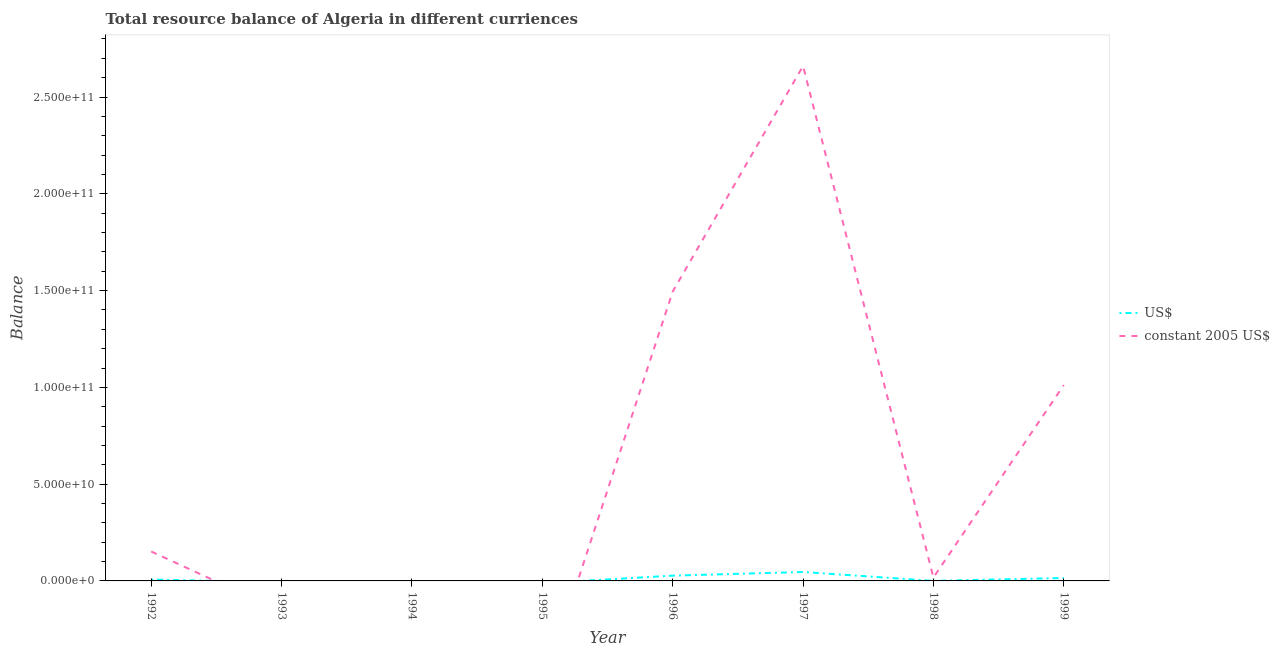How many different coloured lines are there?
Your response must be concise. 2. Does the line corresponding to resource balance in constant us$ intersect with the line corresponding to resource balance in us$?
Ensure brevity in your answer.  Yes. Is the number of lines equal to the number of legend labels?
Offer a terse response. No. What is the resource balance in constant us$ in 1999?
Give a very brief answer. 1.01e+11. Across all years, what is the maximum resource balance in us$?
Provide a succinct answer. 4.61e+09. What is the total resource balance in us$ in the graph?
Provide a short and direct response. 9.59e+09. What is the difference between the resource balance in constant us$ in 1996 and that in 1998?
Provide a short and direct response. 1.48e+11. What is the difference between the resource balance in us$ in 1993 and the resource balance in constant us$ in 1999?
Your answer should be very brief. -1.01e+11. What is the average resource balance in constant us$ per year?
Your answer should be compact. 6.67e+1. In the year 1999, what is the difference between the resource balance in us$ and resource balance in constant us$?
Provide a succinct answer. -9.97e+1. What is the ratio of the resource balance in us$ in 1992 to that in 1996?
Your response must be concise. 0.25. What is the difference between the highest and the second highest resource balance in us$?
Keep it short and to the point. 1.88e+09. What is the difference between the highest and the lowest resource balance in us$?
Your answer should be very brief. 4.61e+09. In how many years, is the resource balance in us$ greater than the average resource balance in us$ taken over all years?
Offer a terse response. 3. Does the resource balance in constant us$ monotonically increase over the years?
Offer a terse response. No. Is the resource balance in constant us$ strictly less than the resource balance in us$ over the years?
Your answer should be very brief. No. How many lines are there?
Provide a short and direct response. 2. What is the difference between two consecutive major ticks on the Y-axis?
Your answer should be compact. 5.00e+1. Are the values on the major ticks of Y-axis written in scientific E-notation?
Provide a short and direct response. Yes. Where does the legend appear in the graph?
Keep it short and to the point. Center right. How many legend labels are there?
Your answer should be very brief. 2. How are the legend labels stacked?
Make the answer very short. Vertical. What is the title of the graph?
Make the answer very short. Total resource balance of Algeria in different curriences. What is the label or title of the X-axis?
Make the answer very short. Year. What is the label or title of the Y-axis?
Your answer should be compact. Balance. What is the Balance in US$ in 1992?
Your answer should be compact. 6.96e+08. What is the Balance in constant 2005 US$ in 1992?
Provide a short and direct response. 1.52e+1. What is the Balance of constant 2005 US$ in 1993?
Ensure brevity in your answer.  0. What is the Balance in constant 2005 US$ in 1994?
Ensure brevity in your answer.  0. What is the Balance of constant 2005 US$ in 1995?
Offer a terse response. 0. What is the Balance in US$ in 1996?
Ensure brevity in your answer.  2.73e+09. What is the Balance of constant 2005 US$ in 1996?
Offer a terse response. 1.49e+11. What is the Balance of US$ in 1997?
Provide a succinct answer. 4.61e+09. What is the Balance of constant 2005 US$ in 1997?
Keep it short and to the point. 2.66e+11. What is the Balance of US$ in 1998?
Your answer should be compact. 3.00e+07. What is the Balance in constant 2005 US$ in 1998?
Make the answer very short. 1.76e+09. What is the Balance in US$ in 1999?
Ensure brevity in your answer.  1.52e+09. What is the Balance in constant 2005 US$ in 1999?
Ensure brevity in your answer.  1.01e+11. Across all years, what is the maximum Balance of US$?
Provide a succinct answer. 4.61e+09. Across all years, what is the maximum Balance of constant 2005 US$?
Ensure brevity in your answer.  2.66e+11. Across all years, what is the minimum Balance in US$?
Your response must be concise. 0. Across all years, what is the minimum Balance of constant 2005 US$?
Offer a terse response. 0. What is the total Balance in US$ in the graph?
Offer a very short reply. 9.59e+09. What is the total Balance in constant 2005 US$ in the graph?
Your answer should be compact. 5.34e+11. What is the difference between the Balance of US$ in 1992 and that in 1996?
Your response must be concise. -2.03e+09. What is the difference between the Balance of constant 2005 US$ in 1992 and that in 1996?
Make the answer very short. -1.34e+11. What is the difference between the Balance in US$ in 1992 and that in 1997?
Give a very brief answer. -3.91e+09. What is the difference between the Balance of constant 2005 US$ in 1992 and that in 1997?
Provide a succinct answer. -2.51e+11. What is the difference between the Balance in US$ in 1992 and that in 1998?
Offer a terse response. 6.66e+08. What is the difference between the Balance of constant 2005 US$ in 1992 and that in 1998?
Your response must be concise. 1.34e+1. What is the difference between the Balance of US$ in 1992 and that in 1999?
Your answer should be very brief. -8.24e+08. What is the difference between the Balance in constant 2005 US$ in 1992 and that in 1999?
Provide a succinct answer. -8.60e+1. What is the difference between the Balance of US$ in 1996 and that in 1997?
Your answer should be very brief. -1.88e+09. What is the difference between the Balance of constant 2005 US$ in 1996 and that in 1997?
Make the answer very short. -1.17e+11. What is the difference between the Balance of US$ in 1996 and that in 1998?
Keep it short and to the point. 2.70e+09. What is the difference between the Balance of constant 2005 US$ in 1996 and that in 1998?
Offer a very short reply. 1.48e+11. What is the difference between the Balance of US$ in 1996 and that in 1999?
Your response must be concise. 1.21e+09. What is the difference between the Balance in constant 2005 US$ in 1996 and that in 1999?
Your response must be concise. 4.83e+1. What is the difference between the Balance in US$ in 1997 and that in 1998?
Your answer should be compact. 4.58e+09. What is the difference between the Balance in constant 2005 US$ in 1997 and that in 1998?
Provide a short and direct response. 2.64e+11. What is the difference between the Balance of US$ in 1997 and that in 1999?
Offer a terse response. 3.09e+09. What is the difference between the Balance in constant 2005 US$ in 1997 and that in 1999?
Your response must be concise. 1.65e+11. What is the difference between the Balance in US$ in 1998 and that in 1999?
Ensure brevity in your answer.  -1.49e+09. What is the difference between the Balance in constant 2005 US$ in 1998 and that in 1999?
Your answer should be very brief. -9.94e+1. What is the difference between the Balance of US$ in 1992 and the Balance of constant 2005 US$ in 1996?
Give a very brief answer. -1.49e+11. What is the difference between the Balance in US$ in 1992 and the Balance in constant 2005 US$ in 1997?
Offer a very short reply. -2.65e+11. What is the difference between the Balance in US$ in 1992 and the Balance in constant 2005 US$ in 1998?
Offer a terse response. -1.07e+09. What is the difference between the Balance in US$ in 1992 and the Balance in constant 2005 US$ in 1999?
Provide a succinct answer. -1.00e+11. What is the difference between the Balance in US$ in 1996 and the Balance in constant 2005 US$ in 1997?
Give a very brief answer. -2.63e+11. What is the difference between the Balance of US$ in 1996 and the Balance of constant 2005 US$ in 1998?
Your answer should be very brief. 9.68e+08. What is the difference between the Balance of US$ in 1996 and the Balance of constant 2005 US$ in 1999?
Offer a very short reply. -9.85e+1. What is the difference between the Balance in US$ in 1997 and the Balance in constant 2005 US$ in 1998?
Your answer should be very brief. 2.85e+09. What is the difference between the Balance in US$ in 1997 and the Balance in constant 2005 US$ in 1999?
Keep it short and to the point. -9.66e+1. What is the difference between the Balance in US$ in 1998 and the Balance in constant 2005 US$ in 1999?
Ensure brevity in your answer.  -1.01e+11. What is the average Balance in US$ per year?
Offer a very short reply. 1.20e+09. What is the average Balance of constant 2005 US$ per year?
Give a very brief answer. 6.67e+1. In the year 1992, what is the difference between the Balance of US$ and Balance of constant 2005 US$?
Give a very brief answer. -1.45e+1. In the year 1996, what is the difference between the Balance of US$ and Balance of constant 2005 US$?
Offer a terse response. -1.47e+11. In the year 1997, what is the difference between the Balance in US$ and Balance in constant 2005 US$?
Make the answer very short. -2.61e+11. In the year 1998, what is the difference between the Balance in US$ and Balance in constant 2005 US$?
Your answer should be very brief. -1.73e+09. In the year 1999, what is the difference between the Balance of US$ and Balance of constant 2005 US$?
Offer a very short reply. -9.97e+1. What is the ratio of the Balance of US$ in 1992 to that in 1996?
Give a very brief answer. 0.26. What is the ratio of the Balance of constant 2005 US$ in 1992 to that in 1996?
Your answer should be compact. 0.1. What is the ratio of the Balance of US$ in 1992 to that in 1997?
Your answer should be compact. 0.15. What is the ratio of the Balance of constant 2005 US$ in 1992 to that in 1997?
Your answer should be very brief. 0.06. What is the ratio of the Balance in US$ in 1992 to that in 1998?
Give a very brief answer. 23.2. What is the ratio of the Balance of constant 2005 US$ in 1992 to that in 1998?
Your response must be concise. 8.63. What is the ratio of the Balance in US$ in 1992 to that in 1999?
Your answer should be compact. 0.46. What is the ratio of the Balance of constant 2005 US$ in 1992 to that in 1999?
Ensure brevity in your answer.  0.15. What is the ratio of the Balance in US$ in 1996 to that in 1997?
Your response must be concise. 0.59. What is the ratio of the Balance of constant 2005 US$ in 1996 to that in 1997?
Make the answer very short. 0.56. What is the ratio of the Balance of US$ in 1996 to that in 1998?
Offer a very short reply. 91. What is the ratio of the Balance of constant 2005 US$ in 1996 to that in 1998?
Offer a terse response. 84.82. What is the ratio of the Balance in US$ in 1996 to that in 1999?
Ensure brevity in your answer.  1.8. What is the ratio of the Balance in constant 2005 US$ in 1996 to that in 1999?
Your answer should be very brief. 1.48. What is the ratio of the Balance of US$ in 1997 to that in 1998?
Offer a terse response. 153.66. What is the ratio of the Balance of constant 2005 US$ in 1997 to that in 1998?
Your answer should be compact. 150.96. What is the ratio of the Balance of US$ in 1997 to that in 1999?
Your answer should be very brief. 3.03. What is the ratio of the Balance of constant 2005 US$ in 1997 to that in 1999?
Provide a short and direct response. 2.63. What is the ratio of the Balance in US$ in 1998 to that in 1999?
Make the answer very short. 0.02. What is the ratio of the Balance in constant 2005 US$ in 1998 to that in 1999?
Make the answer very short. 0.02. What is the difference between the highest and the second highest Balance of US$?
Your answer should be very brief. 1.88e+09. What is the difference between the highest and the second highest Balance in constant 2005 US$?
Provide a short and direct response. 1.17e+11. What is the difference between the highest and the lowest Balance of US$?
Provide a short and direct response. 4.61e+09. What is the difference between the highest and the lowest Balance of constant 2005 US$?
Provide a succinct answer. 2.66e+11. 